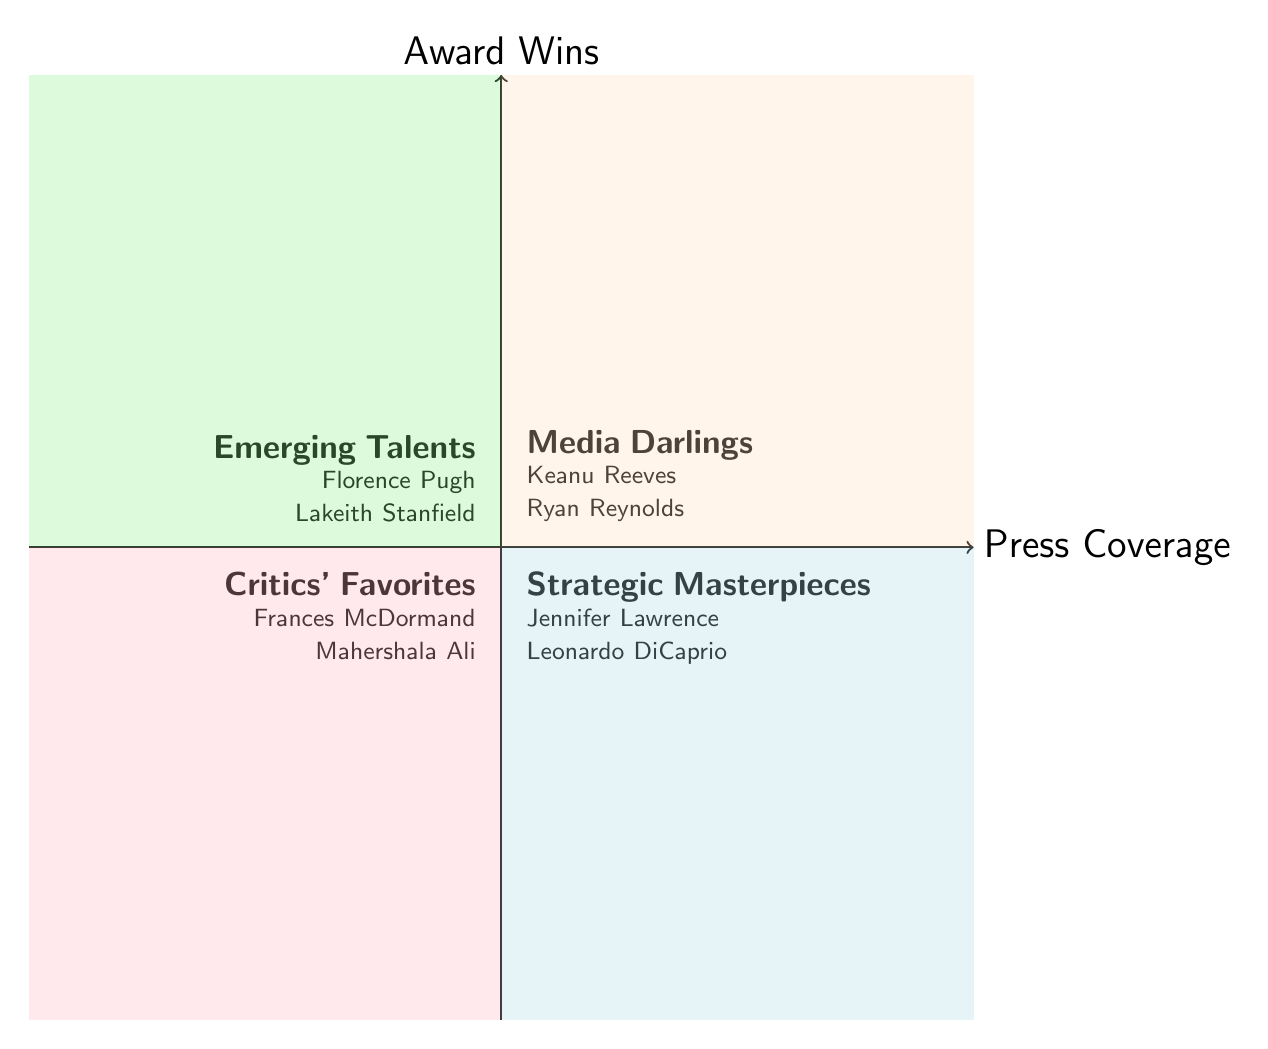What is the title of the quadrant where Jennifer Lawrence is categorized? Jennifer Lawrence is listed in the "Strategic Masterpieces" quadrant, which is located in the top-right area of the diagram.
Answer: Strategic Masterpieces Which actor is an example of a "Media Darling"? The "Media Darlings" quadrant includes actors who have high press coverage but low award wins, and Keanu Reeves is mentioned as an example here.
Answer: Keanu Reeves How many actors are in the "Critics' Favorites" quadrant? The "Critics' Favorites" quadrant contains two examples, Frances McDormand and Mahershala Ali.
Answer: 2 What distinguishes "Emerging Talents" from "Strategic Masterpieces"? "Emerging Talents" consists of actors with low press coverage and low award wins, contrasting with "Strategic Masterpieces," which features actors with high press coverage and high award wins.
Answer: Low press coverage, low award wins Which quadrant has the most prestigious award winners? The "Strategic Masterpieces" quadrant includes actors like Jennifer Lawrence and Leonardo DiCaprio, both of whom have significant award wins and high media coverage.
Answer: Strategic Masterpieces Are any actors in the "Emerging Talents" quadrant featured in major award discussions? Actors in the "Emerging Talents" quadrant, like Florence Pugh and Lakeith Stanfield, are recognized for early career wins but lack major awards, indicating they are still emerging rather than established superstars.
Answer: No What is the significance of the "Press Coverage" axis in this diagram? The "Press Coverage" axis categorizes the actors based on their media visibility, which helps in understanding the relationship between their publicity and their recognition in awards.
Answer: Media visibility Which quadrant contains actors nominated for top-tier awards but with limited wins? The "Media Darlings" quadrant includes actors like Ryan Reynolds, who has some awards but fewer top-tier wins, fitting the description of being recognized yet not heavily awarded.
Answer: Media Darlings 